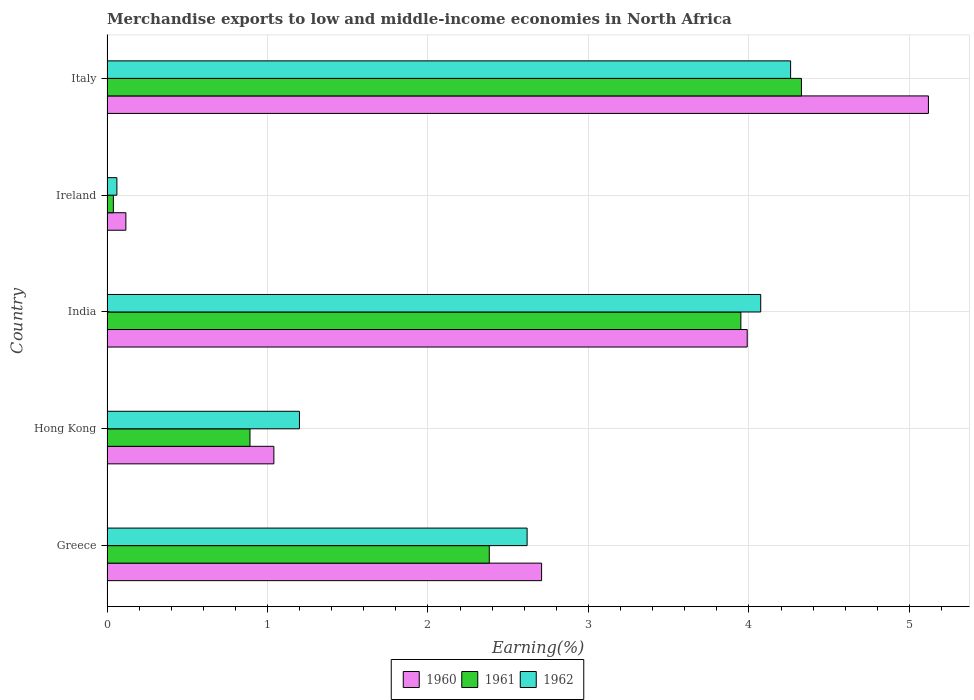How many different coloured bars are there?
Your answer should be compact. 3. Are the number of bars per tick equal to the number of legend labels?
Your answer should be compact. Yes. Are the number of bars on each tick of the Y-axis equal?
Your answer should be very brief. Yes. How many bars are there on the 2nd tick from the top?
Keep it short and to the point. 3. What is the label of the 4th group of bars from the top?
Your answer should be very brief. Hong Kong. What is the percentage of amount earned from merchandise exports in 1961 in Italy?
Make the answer very short. 4.33. Across all countries, what is the maximum percentage of amount earned from merchandise exports in 1960?
Provide a short and direct response. 5.12. Across all countries, what is the minimum percentage of amount earned from merchandise exports in 1960?
Your answer should be very brief. 0.12. In which country was the percentage of amount earned from merchandise exports in 1960 minimum?
Your response must be concise. Ireland. What is the total percentage of amount earned from merchandise exports in 1961 in the graph?
Give a very brief answer. 11.59. What is the difference between the percentage of amount earned from merchandise exports in 1960 in Ireland and that in Italy?
Provide a short and direct response. -5. What is the difference between the percentage of amount earned from merchandise exports in 1962 in Greece and the percentage of amount earned from merchandise exports in 1961 in Italy?
Provide a short and direct response. -1.71. What is the average percentage of amount earned from merchandise exports in 1961 per country?
Provide a short and direct response. 2.32. What is the difference between the percentage of amount earned from merchandise exports in 1961 and percentage of amount earned from merchandise exports in 1962 in Greece?
Your response must be concise. -0.24. What is the ratio of the percentage of amount earned from merchandise exports in 1960 in Greece to that in Italy?
Ensure brevity in your answer.  0.53. Is the difference between the percentage of amount earned from merchandise exports in 1961 in Greece and India greater than the difference between the percentage of amount earned from merchandise exports in 1962 in Greece and India?
Your answer should be compact. No. What is the difference between the highest and the second highest percentage of amount earned from merchandise exports in 1962?
Provide a succinct answer. 0.19. What is the difference between the highest and the lowest percentage of amount earned from merchandise exports in 1961?
Your answer should be compact. 4.29. Is the sum of the percentage of amount earned from merchandise exports in 1962 in Greece and Hong Kong greater than the maximum percentage of amount earned from merchandise exports in 1961 across all countries?
Ensure brevity in your answer.  No. What does the 1st bar from the top in India represents?
Give a very brief answer. 1962. What does the 3rd bar from the bottom in Ireland represents?
Offer a terse response. 1962. Are the values on the major ticks of X-axis written in scientific E-notation?
Provide a succinct answer. No. Does the graph contain grids?
Offer a terse response. Yes. How many legend labels are there?
Keep it short and to the point. 3. What is the title of the graph?
Provide a succinct answer. Merchandise exports to low and middle-income economies in North Africa. What is the label or title of the X-axis?
Ensure brevity in your answer.  Earning(%). What is the label or title of the Y-axis?
Offer a terse response. Country. What is the Earning(%) of 1960 in Greece?
Ensure brevity in your answer.  2.71. What is the Earning(%) in 1961 in Greece?
Provide a succinct answer. 2.38. What is the Earning(%) of 1962 in Greece?
Provide a short and direct response. 2.62. What is the Earning(%) of 1960 in Hong Kong?
Provide a succinct answer. 1.04. What is the Earning(%) of 1961 in Hong Kong?
Your answer should be compact. 0.89. What is the Earning(%) of 1962 in Hong Kong?
Offer a terse response. 1.2. What is the Earning(%) of 1960 in India?
Offer a terse response. 3.99. What is the Earning(%) in 1961 in India?
Your answer should be very brief. 3.95. What is the Earning(%) in 1962 in India?
Your answer should be very brief. 4.07. What is the Earning(%) of 1960 in Ireland?
Keep it short and to the point. 0.12. What is the Earning(%) of 1961 in Ireland?
Offer a very short reply. 0.04. What is the Earning(%) of 1962 in Ireland?
Make the answer very short. 0.06. What is the Earning(%) of 1960 in Italy?
Offer a terse response. 5.12. What is the Earning(%) in 1961 in Italy?
Keep it short and to the point. 4.33. What is the Earning(%) of 1962 in Italy?
Offer a terse response. 4.26. Across all countries, what is the maximum Earning(%) of 1960?
Provide a succinct answer. 5.12. Across all countries, what is the maximum Earning(%) in 1961?
Provide a succinct answer. 4.33. Across all countries, what is the maximum Earning(%) in 1962?
Offer a terse response. 4.26. Across all countries, what is the minimum Earning(%) in 1960?
Provide a short and direct response. 0.12. Across all countries, what is the minimum Earning(%) in 1961?
Your answer should be compact. 0.04. Across all countries, what is the minimum Earning(%) of 1962?
Ensure brevity in your answer.  0.06. What is the total Earning(%) of 1960 in the graph?
Provide a short and direct response. 12.97. What is the total Earning(%) in 1961 in the graph?
Ensure brevity in your answer.  11.59. What is the total Earning(%) of 1962 in the graph?
Give a very brief answer. 12.21. What is the difference between the Earning(%) in 1960 in Greece and that in Hong Kong?
Your response must be concise. 1.67. What is the difference between the Earning(%) in 1961 in Greece and that in Hong Kong?
Provide a short and direct response. 1.49. What is the difference between the Earning(%) of 1962 in Greece and that in Hong Kong?
Provide a short and direct response. 1.42. What is the difference between the Earning(%) of 1960 in Greece and that in India?
Your answer should be very brief. -1.28. What is the difference between the Earning(%) of 1961 in Greece and that in India?
Your answer should be very brief. -1.57. What is the difference between the Earning(%) of 1962 in Greece and that in India?
Your response must be concise. -1.46. What is the difference between the Earning(%) of 1960 in Greece and that in Ireland?
Keep it short and to the point. 2.59. What is the difference between the Earning(%) in 1961 in Greece and that in Ireland?
Offer a very short reply. 2.34. What is the difference between the Earning(%) of 1962 in Greece and that in Ireland?
Your answer should be very brief. 2.56. What is the difference between the Earning(%) of 1960 in Greece and that in Italy?
Your response must be concise. -2.41. What is the difference between the Earning(%) in 1961 in Greece and that in Italy?
Make the answer very short. -1.95. What is the difference between the Earning(%) in 1962 in Greece and that in Italy?
Make the answer very short. -1.64. What is the difference between the Earning(%) of 1960 in Hong Kong and that in India?
Provide a short and direct response. -2.95. What is the difference between the Earning(%) of 1961 in Hong Kong and that in India?
Make the answer very short. -3.06. What is the difference between the Earning(%) of 1962 in Hong Kong and that in India?
Give a very brief answer. -2.87. What is the difference between the Earning(%) of 1960 in Hong Kong and that in Ireland?
Offer a very short reply. 0.92. What is the difference between the Earning(%) in 1961 in Hong Kong and that in Ireland?
Provide a succinct answer. 0.85. What is the difference between the Earning(%) in 1962 in Hong Kong and that in Ireland?
Offer a very short reply. 1.14. What is the difference between the Earning(%) in 1960 in Hong Kong and that in Italy?
Ensure brevity in your answer.  -4.08. What is the difference between the Earning(%) of 1961 in Hong Kong and that in Italy?
Keep it short and to the point. -3.44. What is the difference between the Earning(%) in 1962 in Hong Kong and that in Italy?
Your answer should be compact. -3.06. What is the difference between the Earning(%) in 1960 in India and that in Ireland?
Keep it short and to the point. 3.87. What is the difference between the Earning(%) in 1961 in India and that in Ireland?
Give a very brief answer. 3.91. What is the difference between the Earning(%) in 1962 in India and that in Ireland?
Your answer should be very brief. 4.01. What is the difference between the Earning(%) of 1960 in India and that in Italy?
Your response must be concise. -1.13. What is the difference between the Earning(%) in 1961 in India and that in Italy?
Provide a succinct answer. -0.38. What is the difference between the Earning(%) in 1962 in India and that in Italy?
Your answer should be very brief. -0.19. What is the difference between the Earning(%) in 1960 in Ireland and that in Italy?
Provide a short and direct response. -5. What is the difference between the Earning(%) in 1961 in Ireland and that in Italy?
Ensure brevity in your answer.  -4.29. What is the difference between the Earning(%) of 1962 in Ireland and that in Italy?
Offer a very short reply. -4.2. What is the difference between the Earning(%) in 1960 in Greece and the Earning(%) in 1961 in Hong Kong?
Offer a terse response. 1.82. What is the difference between the Earning(%) of 1960 in Greece and the Earning(%) of 1962 in Hong Kong?
Provide a succinct answer. 1.51. What is the difference between the Earning(%) in 1961 in Greece and the Earning(%) in 1962 in Hong Kong?
Offer a terse response. 1.18. What is the difference between the Earning(%) in 1960 in Greece and the Earning(%) in 1961 in India?
Give a very brief answer. -1.24. What is the difference between the Earning(%) of 1960 in Greece and the Earning(%) of 1962 in India?
Offer a very short reply. -1.37. What is the difference between the Earning(%) in 1961 in Greece and the Earning(%) in 1962 in India?
Offer a very short reply. -1.69. What is the difference between the Earning(%) in 1960 in Greece and the Earning(%) in 1961 in Ireland?
Give a very brief answer. 2.67. What is the difference between the Earning(%) in 1960 in Greece and the Earning(%) in 1962 in Ireland?
Keep it short and to the point. 2.65. What is the difference between the Earning(%) of 1961 in Greece and the Earning(%) of 1962 in Ireland?
Provide a succinct answer. 2.32. What is the difference between the Earning(%) of 1960 in Greece and the Earning(%) of 1961 in Italy?
Make the answer very short. -1.62. What is the difference between the Earning(%) in 1960 in Greece and the Earning(%) in 1962 in Italy?
Your answer should be compact. -1.55. What is the difference between the Earning(%) in 1961 in Greece and the Earning(%) in 1962 in Italy?
Offer a very short reply. -1.88. What is the difference between the Earning(%) in 1960 in Hong Kong and the Earning(%) in 1961 in India?
Offer a very short reply. -2.91. What is the difference between the Earning(%) of 1960 in Hong Kong and the Earning(%) of 1962 in India?
Your answer should be compact. -3.03. What is the difference between the Earning(%) of 1961 in Hong Kong and the Earning(%) of 1962 in India?
Your answer should be compact. -3.18. What is the difference between the Earning(%) of 1960 in Hong Kong and the Earning(%) of 1961 in Ireland?
Your answer should be compact. 1. What is the difference between the Earning(%) in 1960 in Hong Kong and the Earning(%) in 1962 in Ireland?
Your answer should be compact. 0.98. What is the difference between the Earning(%) of 1961 in Hong Kong and the Earning(%) of 1962 in Ireland?
Offer a terse response. 0.83. What is the difference between the Earning(%) of 1960 in Hong Kong and the Earning(%) of 1961 in Italy?
Your answer should be very brief. -3.29. What is the difference between the Earning(%) of 1960 in Hong Kong and the Earning(%) of 1962 in Italy?
Keep it short and to the point. -3.22. What is the difference between the Earning(%) of 1961 in Hong Kong and the Earning(%) of 1962 in Italy?
Keep it short and to the point. -3.37. What is the difference between the Earning(%) of 1960 in India and the Earning(%) of 1961 in Ireland?
Give a very brief answer. 3.95. What is the difference between the Earning(%) of 1960 in India and the Earning(%) of 1962 in Ireland?
Give a very brief answer. 3.93. What is the difference between the Earning(%) in 1961 in India and the Earning(%) in 1962 in Ireland?
Keep it short and to the point. 3.89. What is the difference between the Earning(%) of 1960 in India and the Earning(%) of 1961 in Italy?
Provide a succinct answer. -0.34. What is the difference between the Earning(%) of 1960 in India and the Earning(%) of 1962 in Italy?
Provide a succinct answer. -0.27. What is the difference between the Earning(%) of 1961 in India and the Earning(%) of 1962 in Italy?
Your answer should be compact. -0.31. What is the difference between the Earning(%) in 1960 in Ireland and the Earning(%) in 1961 in Italy?
Provide a succinct answer. -4.21. What is the difference between the Earning(%) of 1960 in Ireland and the Earning(%) of 1962 in Italy?
Offer a very short reply. -4.14. What is the difference between the Earning(%) in 1961 in Ireland and the Earning(%) in 1962 in Italy?
Ensure brevity in your answer.  -4.22. What is the average Earning(%) in 1960 per country?
Offer a terse response. 2.59. What is the average Earning(%) in 1961 per country?
Your response must be concise. 2.32. What is the average Earning(%) of 1962 per country?
Make the answer very short. 2.44. What is the difference between the Earning(%) in 1960 and Earning(%) in 1961 in Greece?
Provide a succinct answer. 0.33. What is the difference between the Earning(%) of 1960 and Earning(%) of 1962 in Greece?
Provide a succinct answer. 0.09. What is the difference between the Earning(%) in 1961 and Earning(%) in 1962 in Greece?
Offer a very short reply. -0.24. What is the difference between the Earning(%) of 1960 and Earning(%) of 1961 in Hong Kong?
Your response must be concise. 0.15. What is the difference between the Earning(%) in 1960 and Earning(%) in 1962 in Hong Kong?
Keep it short and to the point. -0.16. What is the difference between the Earning(%) in 1961 and Earning(%) in 1962 in Hong Kong?
Your response must be concise. -0.31. What is the difference between the Earning(%) of 1960 and Earning(%) of 1961 in India?
Your response must be concise. 0.04. What is the difference between the Earning(%) in 1960 and Earning(%) in 1962 in India?
Make the answer very short. -0.08. What is the difference between the Earning(%) in 1961 and Earning(%) in 1962 in India?
Your response must be concise. -0.12. What is the difference between the Earning(%) of 1960 and Earning(%) of 1961 in Ireland?
Keep it short and to the point. 0.08. What is the difference between the Earning(%) in 1960 and Earning(%) in 1962 in Ireland?
Your answer should be very brief. 0.06. What is the difference between the Earning(%) of 1961 and Earning(%) of 1962 in Ireland?
Ensure brevity in your answer.  -0.02. What is the difference between the Earning(%) of 1960 and Earning(%) of 1961 in Italy?
Your answer should be very brief. 0.79. What is the difference between the Earning(%) of 1960 and Earning(%) of 1962 in Italy?
Offer a very short reply. 0.86. What is the difference between the Earning(%) in 1961 and Earning(%) in 1962 in Italy?
Make the answer very short. 0.07. What is the ratio of the Earning(%) of 1960 in Greece to that in Hong Kong?
Give a very brief answer. 2.6. What is the ratio of the Earning(%) of 1961 in Greece to that in Hong Kong?
Give a very brief answer. 2.67. What is the ratio of the Earning(%) in 1962 in Greece to that in Hong Kong?
Your response must be concise. 2.18. What is the ratio of the Earning(%) in 1960 in Greece to that in India?
Offer a very short reply. 0.68. What is the ratio of the Earning(%) in 1961 in Greece to that in India?
Offer a terse response. 0.6. What is the ratio of the Earning(%) in 1962 in Greece to that in India?
Offer a very short reply. 0.64. What is the ratio of the Earning(%) of 1960 in Greece to that in Ireland?
Make the answer very short. 23.03. What is the ratio of the Earning(%) in 1961 in Greece to that in Ireland?
Your answer should be very brief. 60.05. What is the ratio of the Earning(%) of 1962 in Greece to that in Ireland?
Give a very brief answer. 42.46. What is the ratio of the Earning(%) of 1960 in Greece to that in Italy?
Offer a terse response. 0.53. What is the ratio of the Earning(%) of 1961 in Greece to that in Italy?
Your answer should be very brief. 0.55. What is the ratio of the Earning(%) in 1962 in Greece to that in Italy?
Your answer should be compact. 0.61. What is the ratio of the Earning(%) in 1960 in Hong Kong to that in India?
Offer a very short reply. 0.26. What is the ratio of the Earning(%) in 1961 in Hong Kong to that in India?
Give a very brief answer. 0.23. What is the ratio of the Earning(%) of 1962 in Hong Kong to that in India?
Offer a terse response. 0.29. What is the ratio of the Earning(%) of 1960 in Hong Kong to that in Ireland?
Offer a very short reply. 8.84. What is the ratio of the Earning(%) in 1961 in Hong Kong to that in Ireland?
Offer a terse response. 22.46. What is the ratio of the Earning(%) of 1962 in Hong Kong to that in Ireland?
Provide a succinct answer. 19.45. What is the ratio of the Earning(%) of 1960 in Hong Kong to that in Italy?
Give a very brief answer. 0.2. What is the ratio of the Earning(%) of 1961 in Hong Kong to that in Italy?
Ensure brevity in your answer.  0.21. What is the ratio of the Earning(%) of 1962 in Hong Kong to that in Italy?
Offer a very short reply. 0.28. What is the ratio of the Earning(%) of 1960 in India to that in Ireland?
Make the answer very short. 33.93. What is the ratio of the Earning(%) of 1961 in India to that in Ireland?
Provide a short and direct response. 99.57. What is the ratio of the Earning(%) in 1962 in India to that in Ireland?
Your answer should be compact. 66.07. What is the ratio of the Earning(%) in 1960 in India to that in Italy?
Offer a terse response. 0.78. What is the ratio of the Earning(%) of 1961 in India to that in Italy?
Make the answer very short. 0.91. What is the ratio of the Earning(%) of 1962 in India to that in Italy?
Provide a succinct answer. 0.96. What is the ratio of the Earning(%) of 1960 in Ireland to that in Italy?
Keep it short and to the point. 0.02. What is the ratio of the Earning(%) of 1961 in Ireland to that in Italy?
Provide a succinct answer. 0.01. What is the ratio of the Earning(%) of 1962 in Ireland to that in Italy?
Provide a short and direct response. 0.01. What is the difference between the highest and the second highest Earning(%) of 1960?
Provide a succinct answer. 1.13. What is the difference between the highest and the second highest Earning(%) of 1961?
Your response must be concise. 0.38. What is the difference between the highest and the second highest Earning(%) of 1962?
Keep it short and to the point. 0.19. What is the difference between the highest and the lowest Earning(%) in 1960?
Provide a short and direct response. 5. What is the difference between the highest and the lowest Earning(%) in 1961?
Offer a terse response. 4.29. What is the difference between the highest and the lowest Earning(%) in 1962?
Make the answer very short. 4.2. 